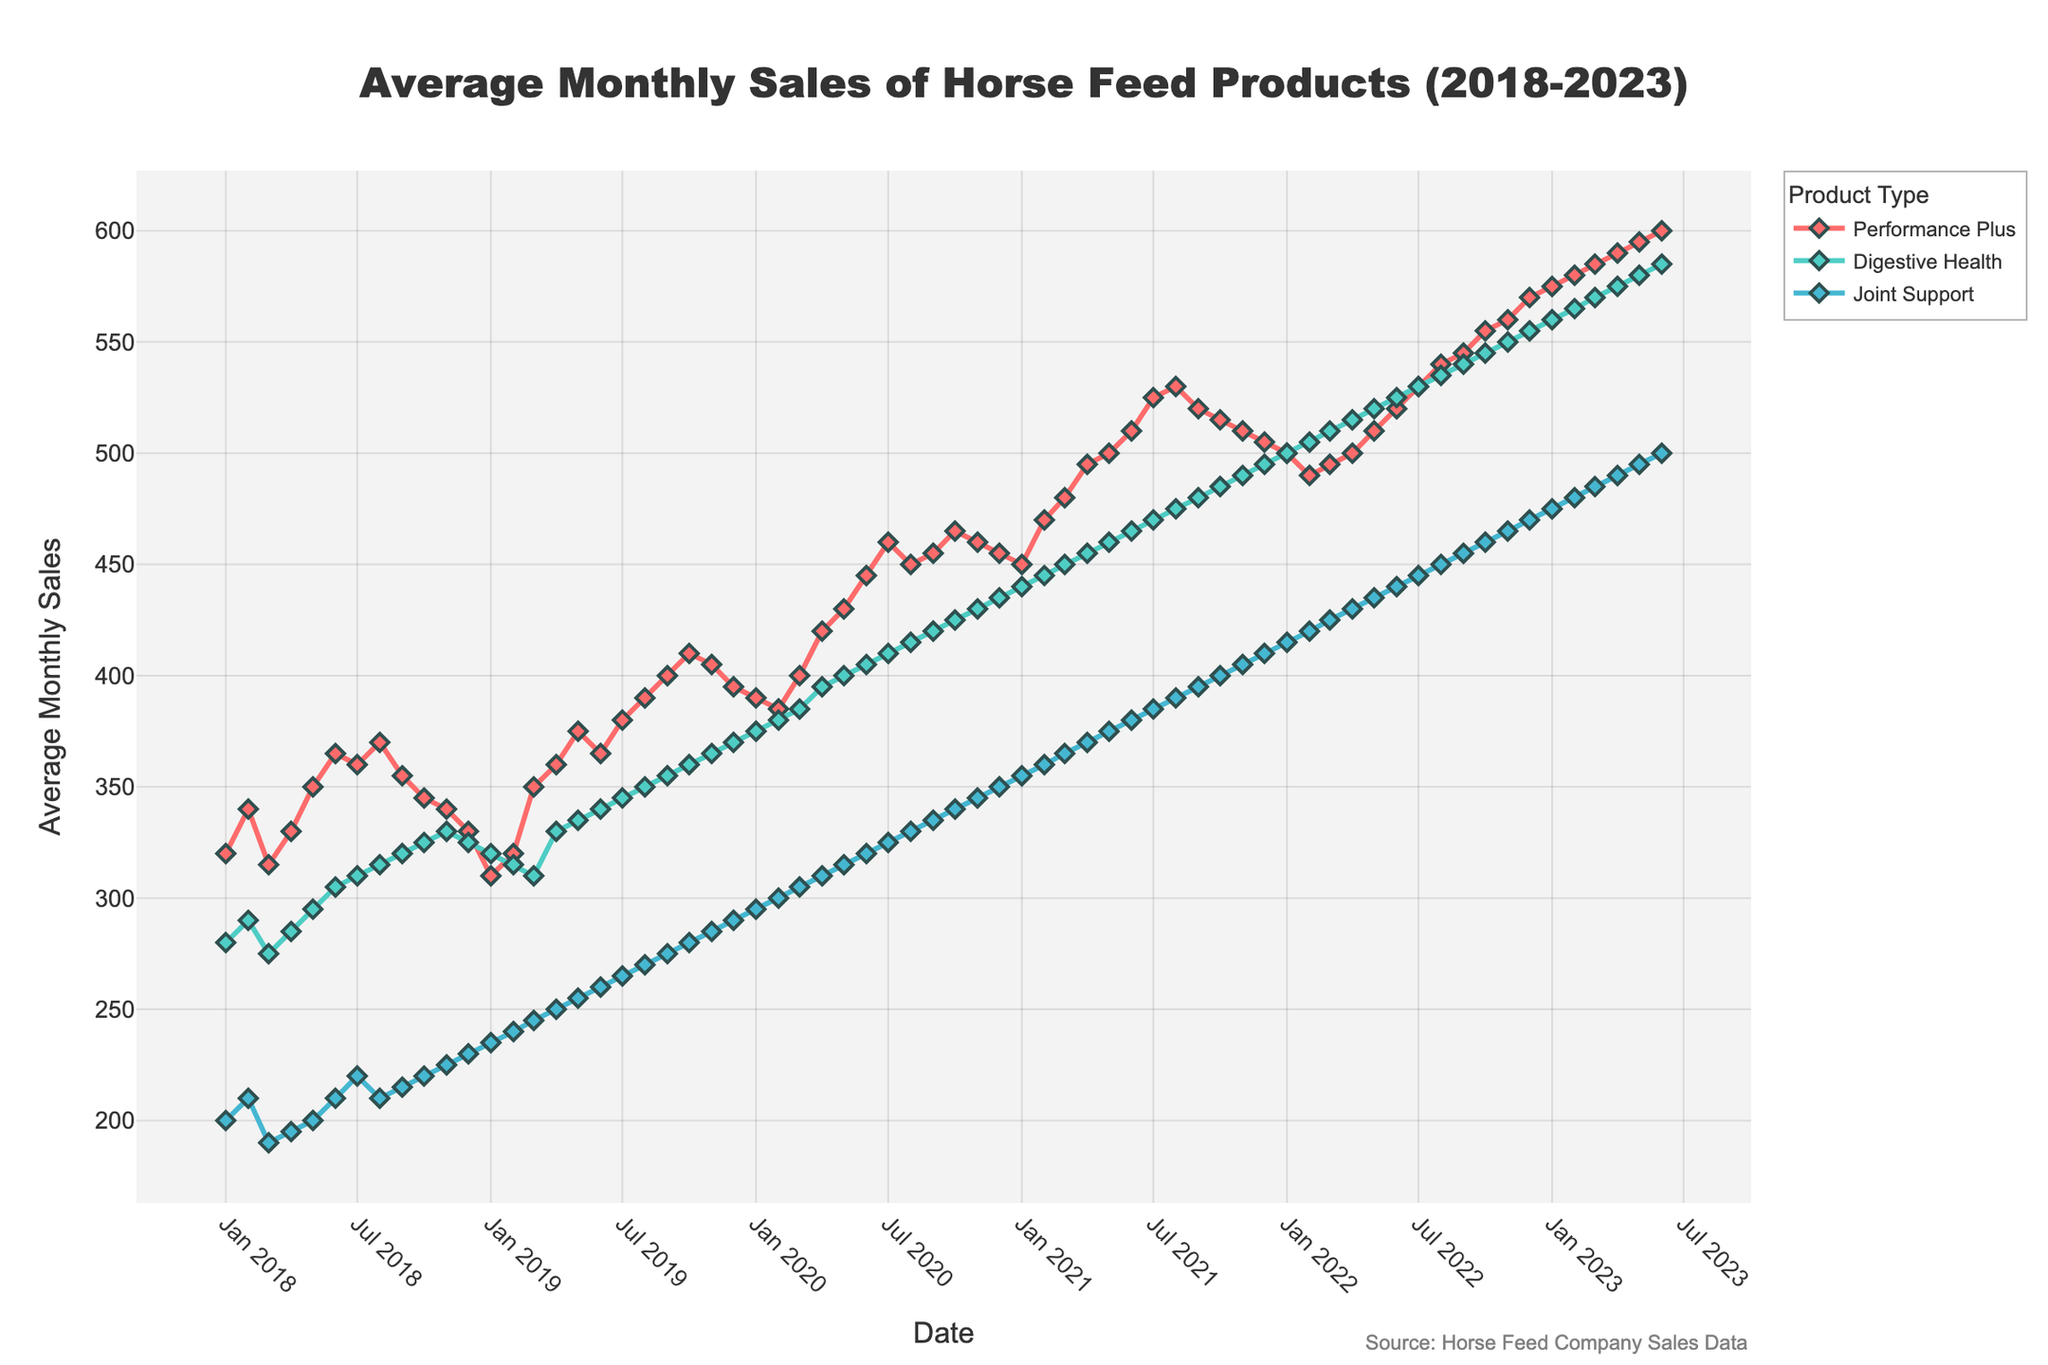What is the title of the figure? The title is typically displayed at the top of the figure. It summarizes the content being visualized.
Answer: Average Monthly Sales of Horse Feed Products (2018-2023) Which Product Type shows the highest sales in the latest month available on the plot? Look at the sales values for the latest date (June 2023) and compare the sales of each product type.
Answer: Performance Plus How does the average monthly sales trend for Digestive Health compare to Performance Plus over the 5-year period? Observe the general direction of the lines for both product types over the 5-year period. Digestive Health shows a steady increase, while Performance Plus exhibits a more pronounced upward trend.
Answer: Performance Plus has a steeper upward trend What is the average monthly sales difference between Performance Plus and Joint Support in January 2023? Check the sales values for January 2023 for both Performance Plus and Joint Support, then subtract the Joint Support value from the Performance Plus value.
Answer: 100 During which year did Performance Plus show the most significant sales growth? Compare the sales values at the beginning and end of each year for Performance Plus to identify the year with the largest increase.
Answer: 2021 What are the axis titles on the plot? Axis titles are generally located along the x and y axes to describe what each axis represents.
Answer: Date (x-axis) and Average Monthly Sales (y-axis) Which product type reached the 500 average monthly sales mark first? Compare when each product type's sales line first crosses or reaches the 500 sales mark.
Answer: Performance Plus What is the difference in average monthly sales between the highest and lowest points for Digestive Health over the 5-year period? Identify the highest and lowest sales values for Digestive Health within the time frame and subtract the lowest from the highest.
Answer: 305 Did Joint Support ever surpass 450 average monthly sales during the 5-year period? Check the sales values for Joint Support and see if any point exceeds 450.
Answer: Yes In which month and year did Performance Plus first exceed 400 average monthly sales? Identify the point on the time series plot where Performance Plus sales surpassed 400 for the first time.
Answer: September 2019 